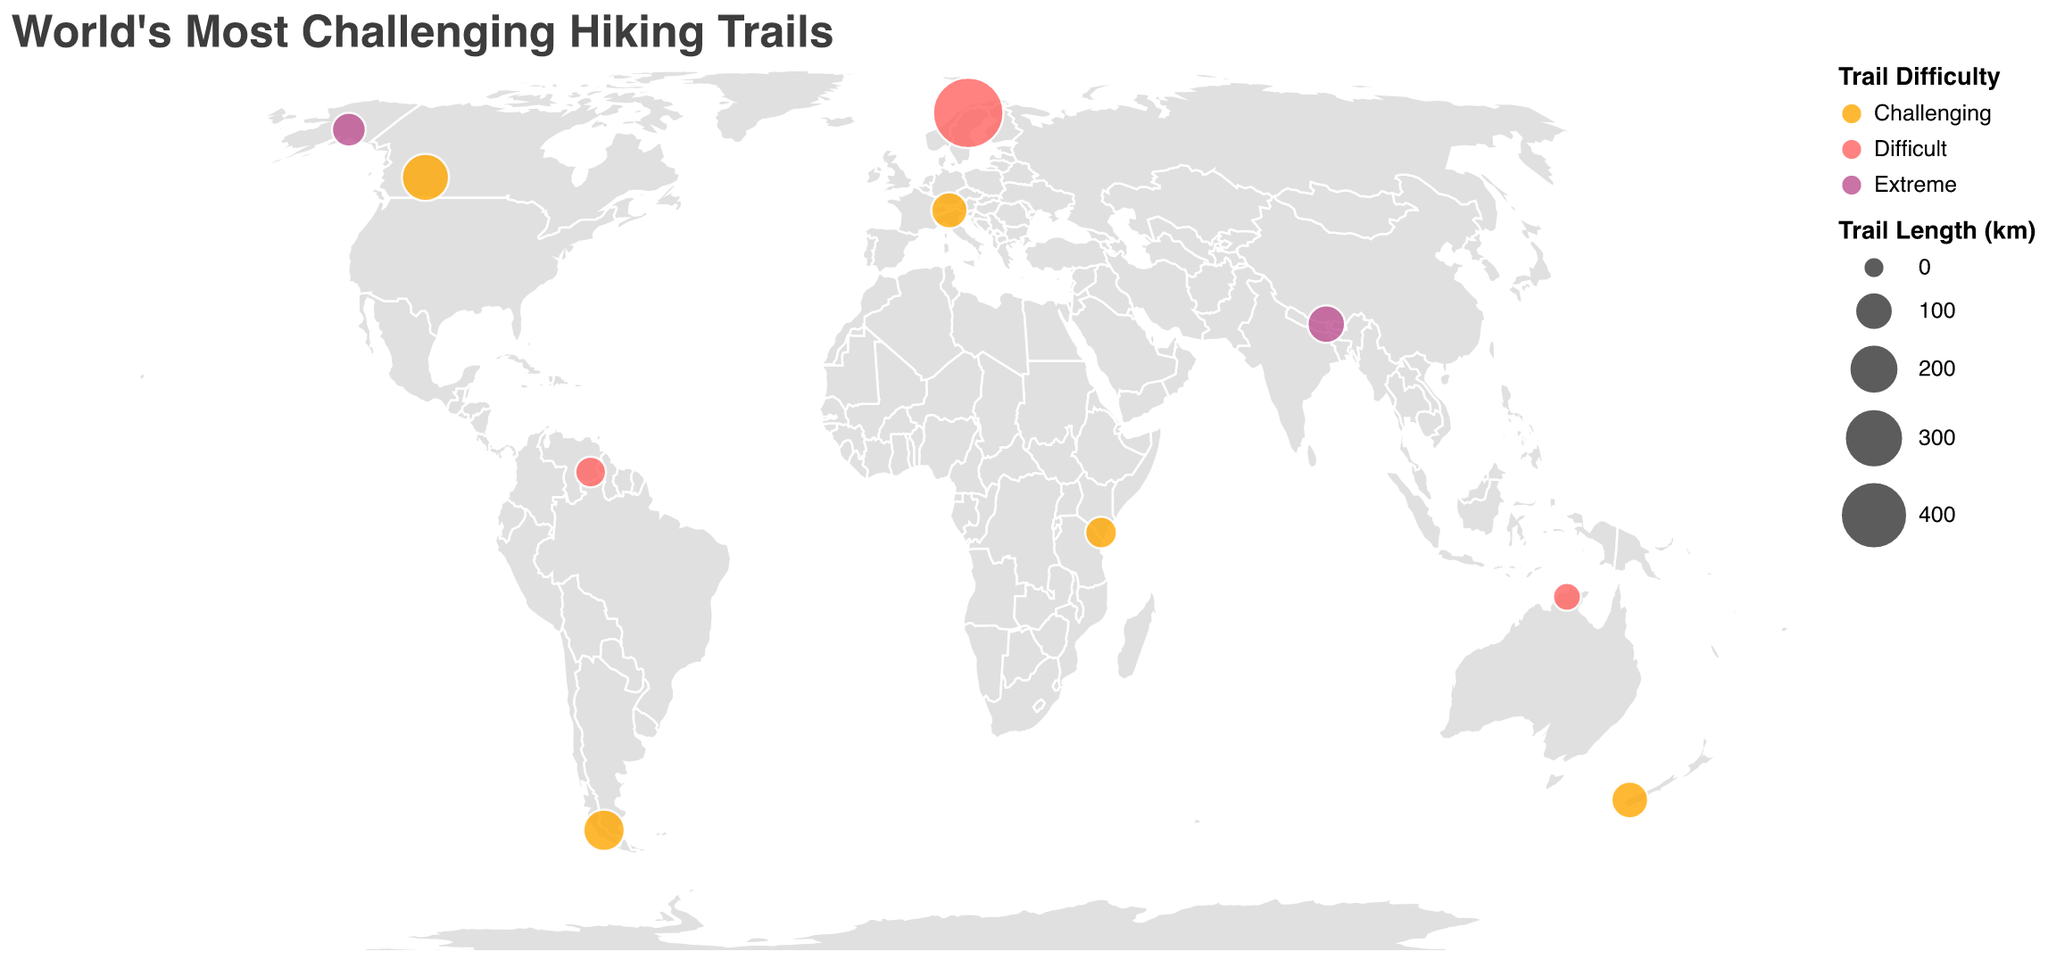What is the title of the plot? The title of the plot is shown at the top, indicating the overall theme of the plot.
Answer: World's Most Challenging Hiking Trails How many national parks and challenging hiking trails are highlighted on the map? Count the distinctive circles plotted on the map, each representing a national park and a hiking trail.
Answer: 10 Which hiking trail has the highest elevation gain shown on the map? Look for the tooltip information related to the "Elevation Gain (m)" and identify the highest value.
Answer: Kungsleden in Sarek, Sweden with 6000m What color represents 'Extreme' difficulty on the map and which trails are marked as 'Extreme'? Analyze the map legend for the color codes assigned to different difficulties and identify the trails marked in that color.
Answer: Purple color; Stampede Trail in Denali, USA and Green Lake Trek in Khangchendzonga, India Which trail is the longest and in which national park is it located? Check the tooltip data for the "Length (km)" and identify the highest value and corresponding park.
Answer: Kungsleden in Sarek, Sweden with 440 km Which trail has the lowest elevation gain, and what is it? Compare the elevation gain values in the tooltips and identify the lowest value.
Answer: Jim Jim Falls Trail in Kakadu, Australia with 800m How many trails have a 'Challenging' difficulty rating, and which trails are they? Filter the trails based on the 'Challenging' difficulty label and count them.
Answer: 5; O Circuit, Dusky Track, North Boundary Trail, Lugard Falls Trek, Pass dal Fuorn Which country appears most frequently in the list of trails, and how many trails are located there? Check the tooltip data for the "Country" label and count the occurrences of each country.
Answer: Two; USA and New Zealand each have one trail 